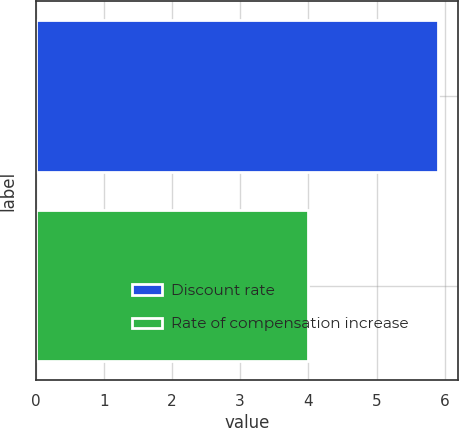Convert chart to OTSL. <chart><loc_0><loc_0><loc_500><loc_500><bar_chart><fcel>Discount rate<fcel>Rate of compensation increase<nl><fcel>5.9<fcel>4<nl></chart> 